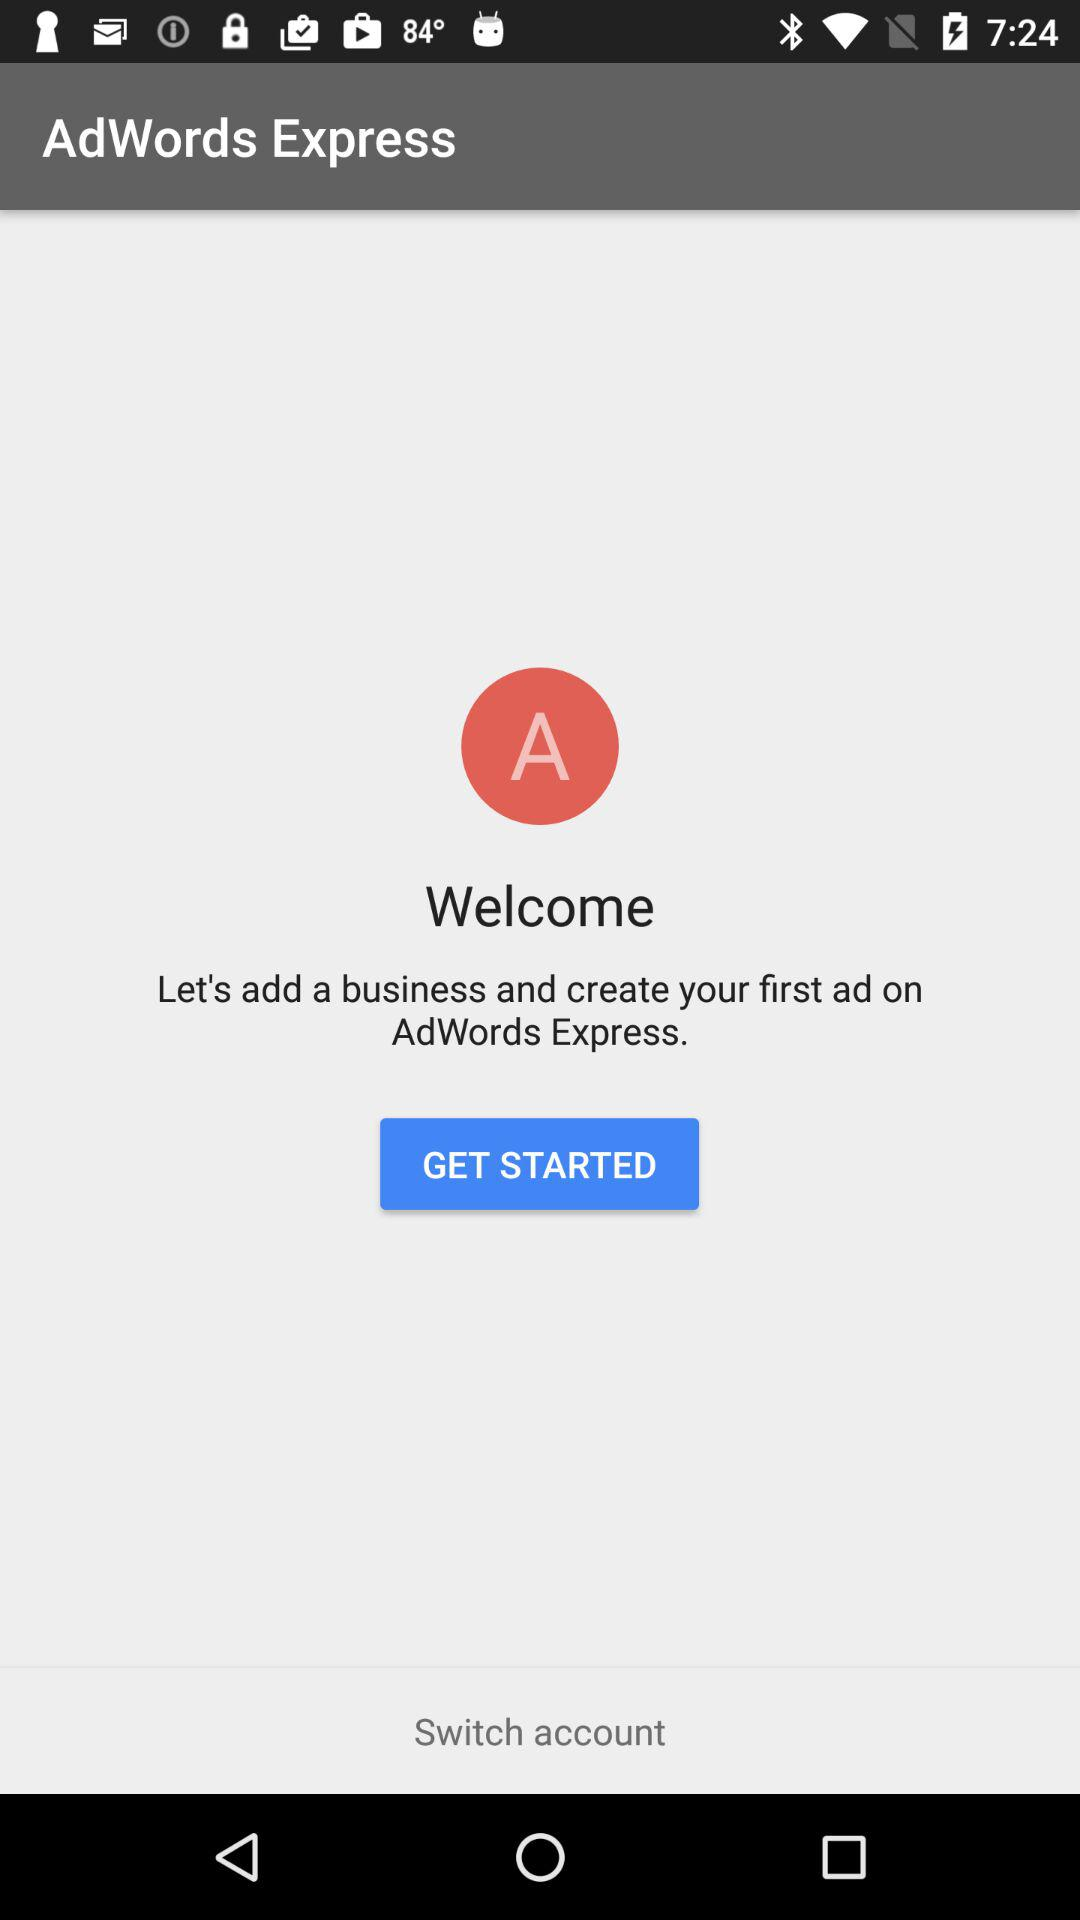What is the app name? The app name is "AdWords Express". 